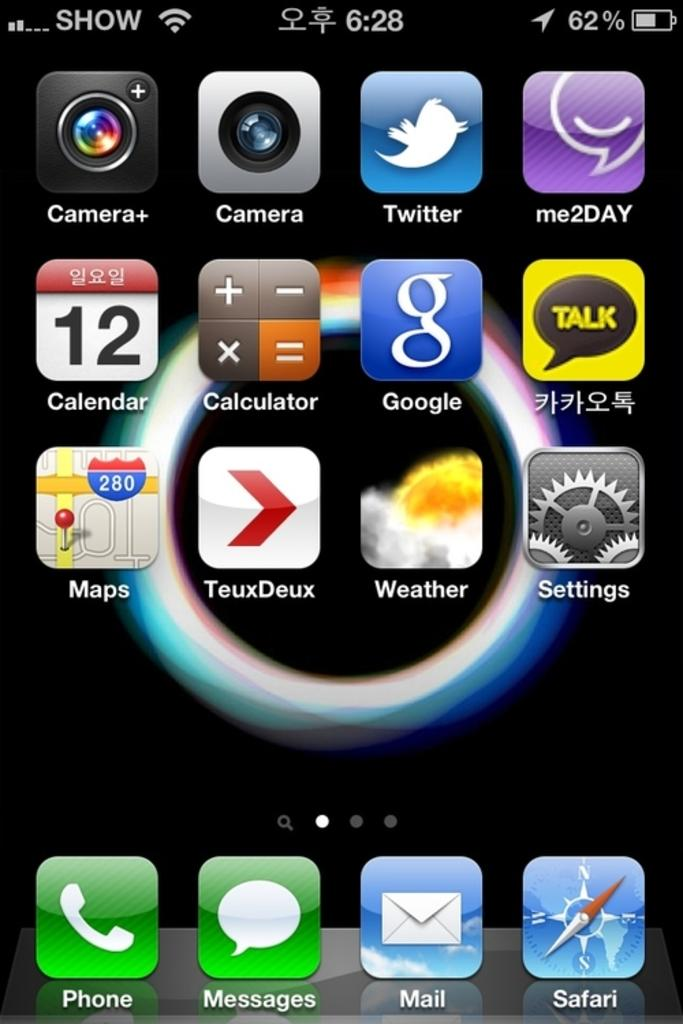<image>
Provide a brief description of the given image. A close up of a smart phone with the first app being the phone call icon. 